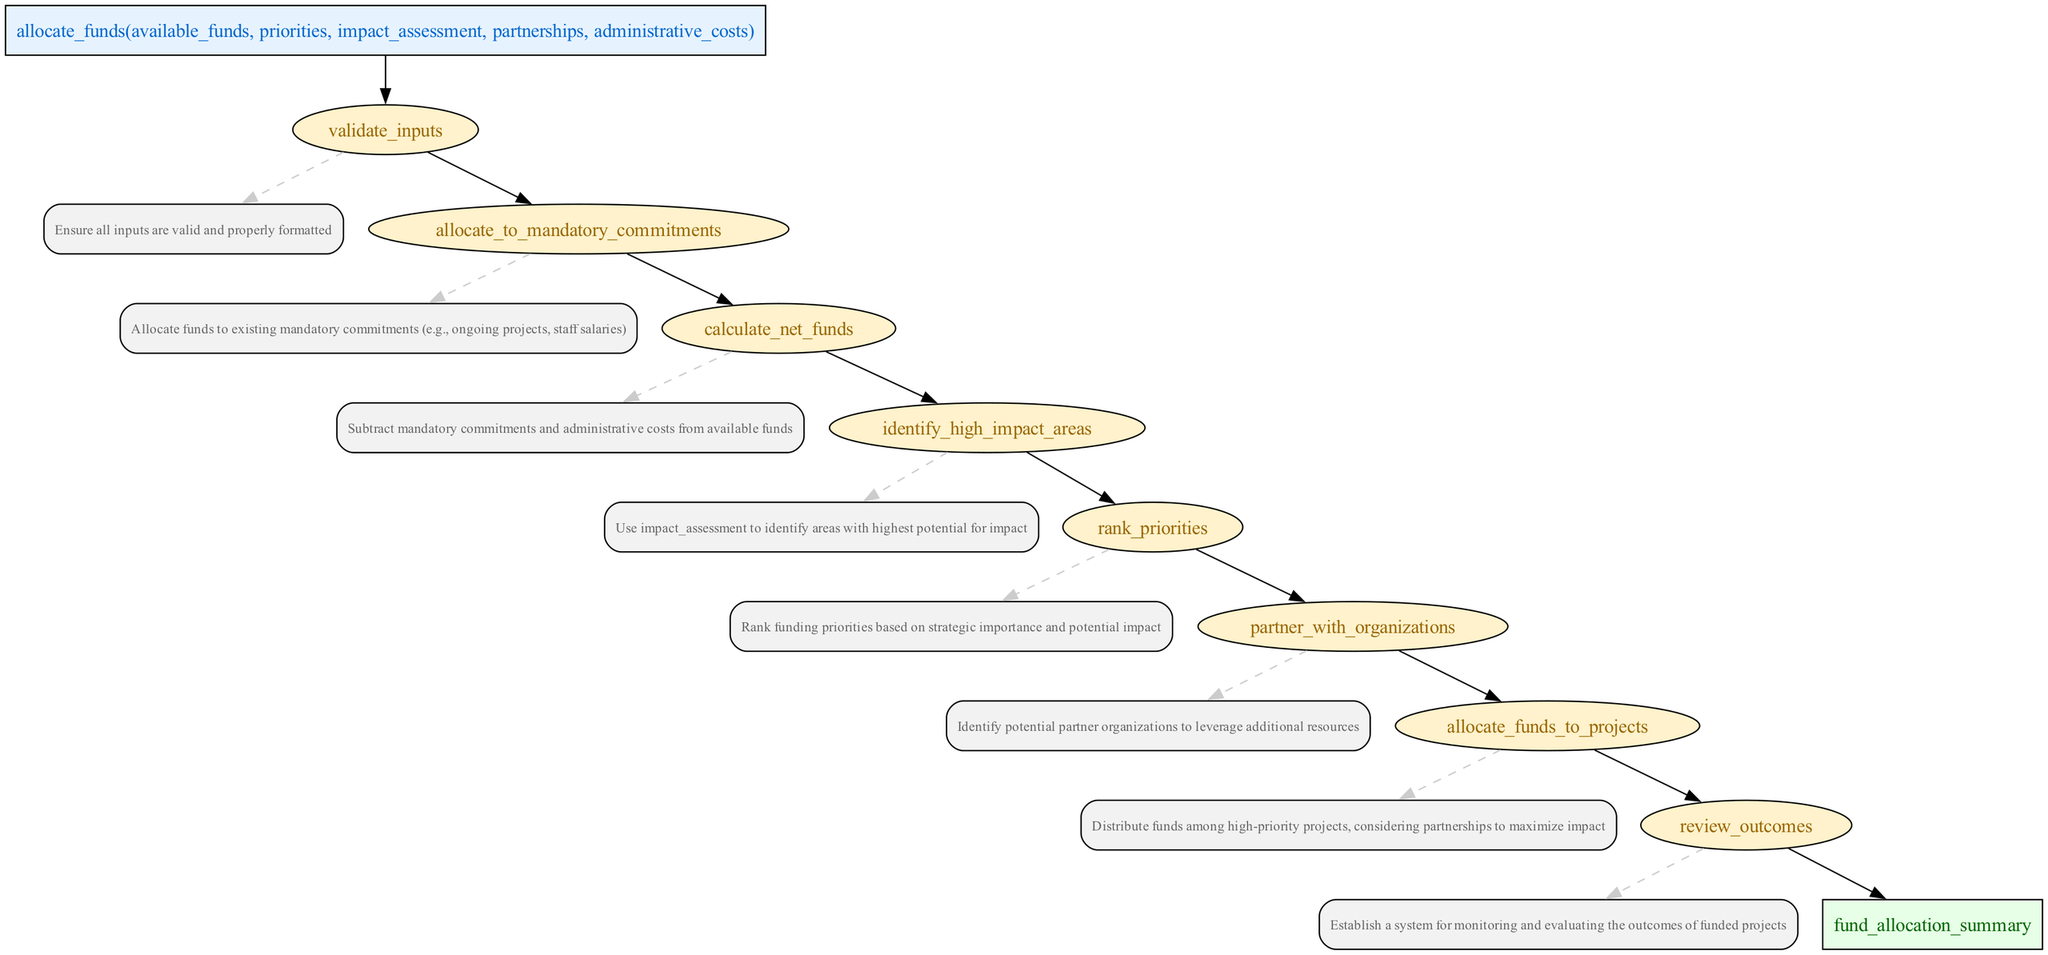What is the first step in the fund allocation strategy? The first step is to validate inputs, as shown in the flowchart where it is the first process node that follows the function node.
Answer: validate inputs How many processes are involved in the fund allocation strategy? There are a total of eight process nodes as shown in the diagram, each representing a specific step in the allocation strategy.
Answer: eight Which process identifies high-impact areas? The process that identifies high-impact areas is called "identify high impact areas," according to the flowchart where it follows the calculation of net funds.
Answer: identify high impact areas What follows after allocating funds to mandatory commitments? After allocating funds to mandatory commitments, the next step is to calculate net funds, indicating that it is a sequential process in the allocation strategy.
Answer: calculate net funds What type of organizations does the fund allocation strategy aim to partner with? The strategy aims to partner with organizations that can leverage additional resources, indicated specifically in the partnered process within the diagram.
Answer: organizations Which process provides a summary of fund allocation? The process that provides a summary of fund allocation is the return statement which comes after reviewing outcomes in the flow.
Answer: fund allocation summary What does the final step in the fund allocation strategy involve? The final step involves reviewing outcomes, which focuses on establishing a system for monitoring and evaluating the funded projects' outcomes as indicated in the last process node.
Answer: reviewing outcomes How is the next step determined after calculating net funds? The next step after calculating net funds is determined by identifying high-impact areas, as shown in the flow of the diagram that links these two processes directly.
Answer: identifying high impact areas What is the purpose of allocating funds to projects? The purpose of allocating funds to projects is to distribute funds among high-priority projects while considering partnerships for maximizing impact, clearly stated in the corresponding process description.
Answer: maximize impact 